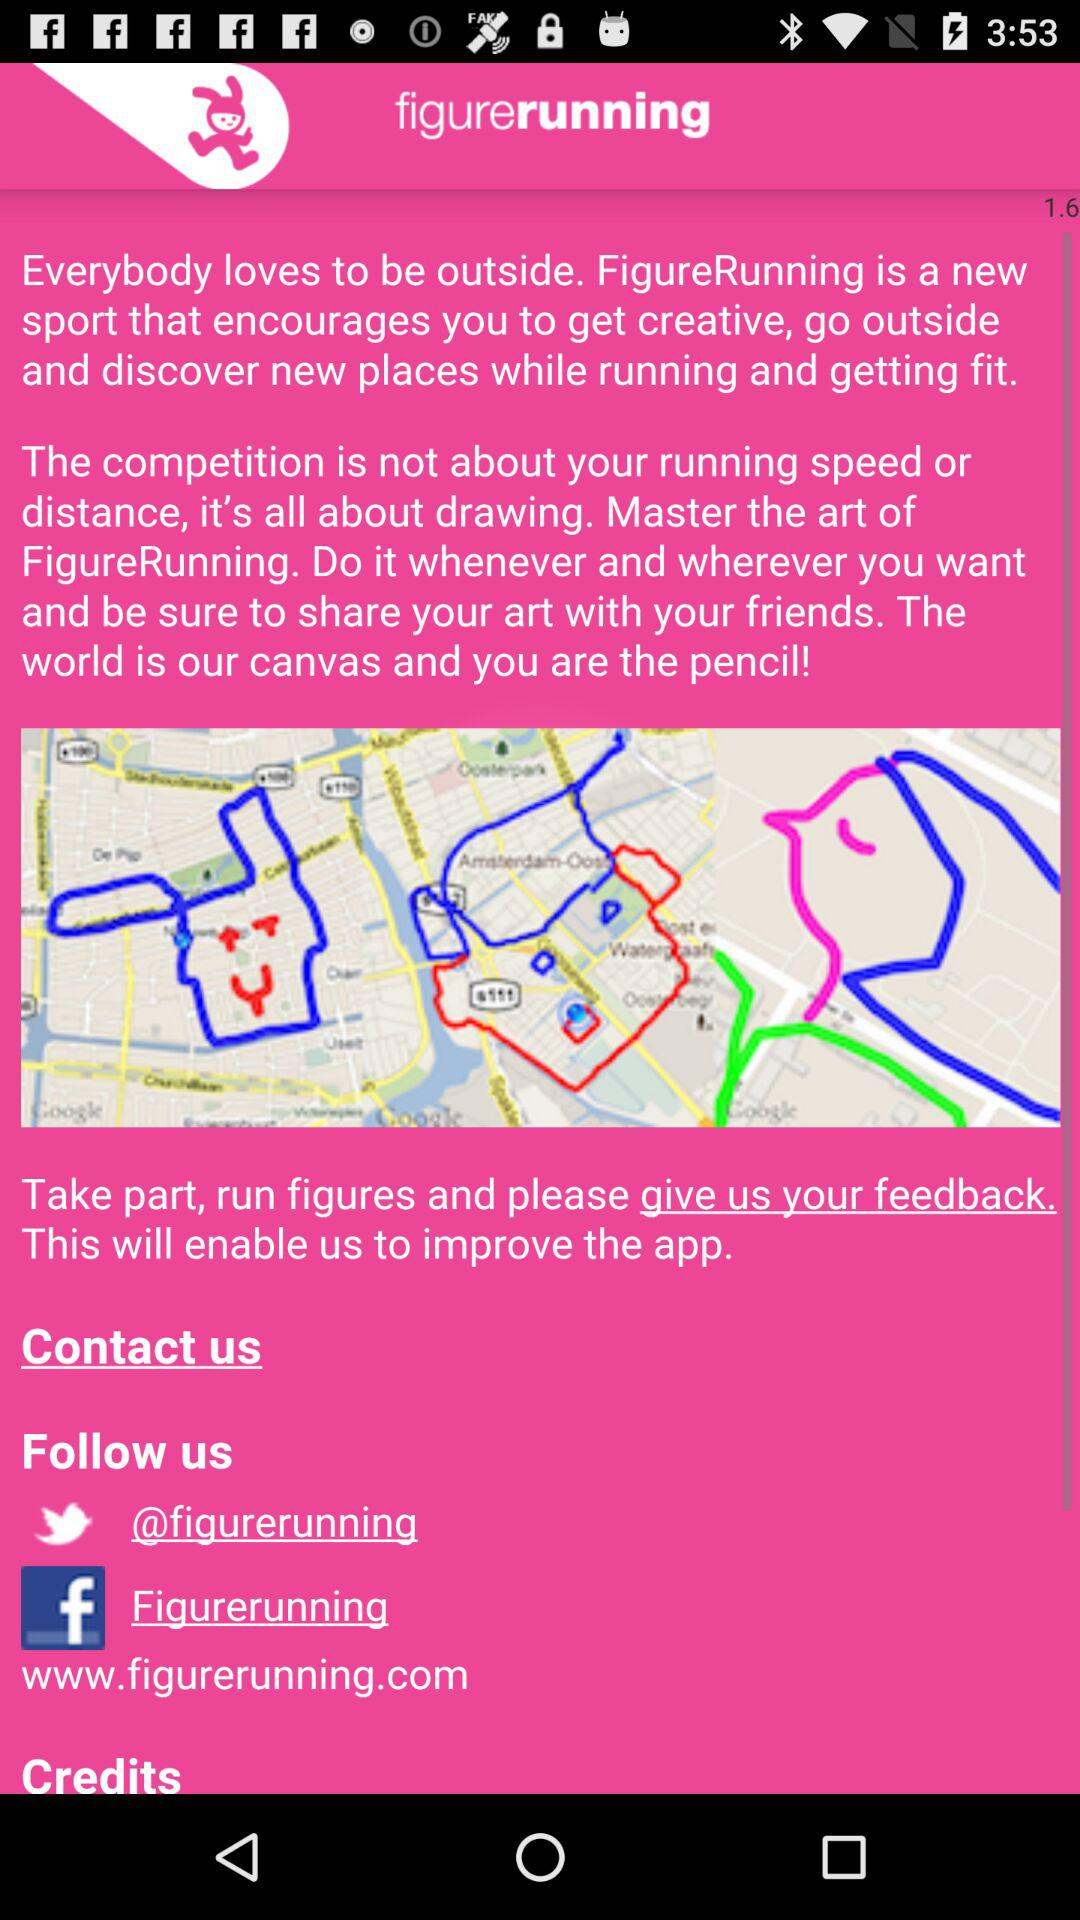What is the application name? The application name is "figurerunning". 